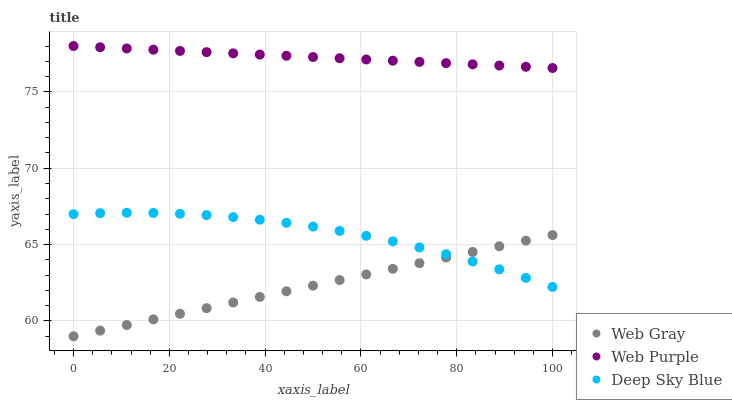Does Web Gray have the minimum area under the curve?
Answer yes or no. Yes. Does Web Purple have the maximum area under the curve?
Answer yes or no. Yes. Does Deep Sky Blue have the minimum area under the curve?
Answer yes or no. No. Does Deep Sky Blue have the maximum area under the curve?
Answer yes or no. No. Is Web Gray the smoothest?
Answer yes or no. Yes. Is Deep Sky Blue the roughest?
Answer yes or no. Yes. Is Deep Sky Blue the smoothest?
Answer yes or no. No. Is Web Gray the roughest?
Answer yes or no. No. Does Web Gray have the lowest value?
Answer yes or no. Yes. Does Deep Sky Blue have the lowest value?
Answer yes or no. No. Does Web Purple have the highest value?
Answer yes or no. Yes. Does Deep Sky Blue have the highest value?
Answer yes or no. No. Is Web Gray less than Web Purple?
Answer yes or no. Yes. Is Web Purple greater than Web Gray?
Answer yes or no. Yes. Does Deep Sky Blue intersect Web Gray?
Answer yes or no. Yes. Is Deep Sky Blue less than Web Gray?
Answer yes or no. No. Is Deep Sky Blue greater than Web Gray?
Answer yes or no. No. Does Web Gray intersect Web Purple?
Answer yes or no. No. 